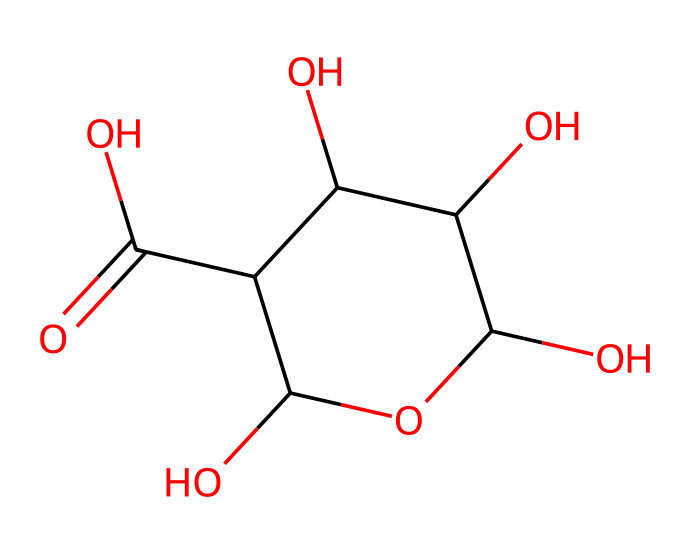What is the molecular formula of glucuronic acid? To determine the molecular formula, we count each type of atom in the structure represented by the SMILES. Counting carbons (C), hydrogens (H), and oxygens (O) gives us: 6 carbons, 10 hydrogens, and 8 oxygens. Thus, the molecular formula is C6H10O8.
Answer: C6H10O8 How many hydroxyl (–OH) groups are present in glucuronic acid? Examining the chemical structure, we identify the hydroxyl groups connected to the carbons. There are three –OH groups attached to the cyclic structure, thus, glucuronic acid has three hydroxyl groups.
Answer: three What type of chemical compound is glucuronic acid classified as? Glucuronic acid is characterized as a sugar acid due to the presence of carboxylic acid functional group along with hydroxyl groups. This classification is standard for molecules that contain both sugar and acid functionalities.
Answer: sugar acid Which functional groups are present in glucuronic acid? The chemical structure shows the presence of hydroxyl groups (–OH) and a carboxylic acid group (–COOH). These are the primary functional groups visible in the compound, confirming its classification.
Answer: hydroxyl and carboxylic acid How many stereocenters are present in glucuronic acid? To identify stereocenters, we look at the carbon atoms with four different substituents. In glucuronic acid, there are four stereocenters based on this descriptor, indicating its chiral nature.
Answer: four What is the role of glucuronic acid in drug metabolism? Glucuronic acid plays a significant role in drug metabolism primarily as a conjugating agent, which enhances drug solubility and facilitates excretion via urine. This is due to its ability to form glucuronides with various drugs.
Answer: conjugating agent 